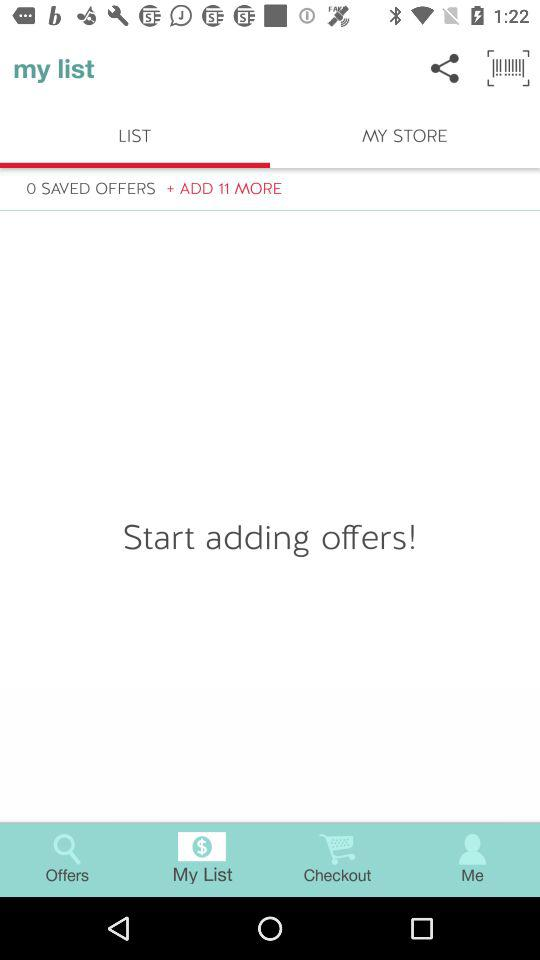How many offers are saved in "my list"? There are 0 saved offers in "my list". 